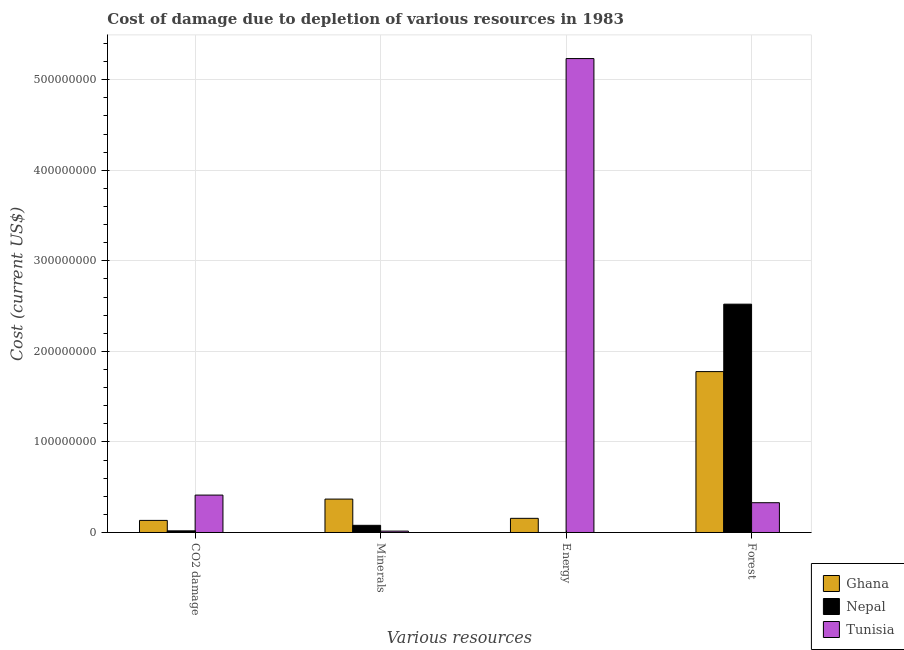How many different coloured bars are there?
Offer a terse response. 3. How many groups of bars are there?
Your answer should be very brief. 4. Are the number of bars per tick equal to the number of legend labels?
Your answer should be compact. Yes. Are the number of bars on each tick of the X-axis equal?
Give a very brief answer. Yes. What is the label of the 2nd group of bars from the left?
Offer a terse response. Minerals. What is the cost of damage due to depletion of energy in Tunisia?
Ensure brevity in your answer.  5.23e+08. Across all countries, what is the maximum cost of damage due to depletion of coal?
Give a very brief answer. 4.13e+07. Across all countries, what is the minimum cost of damage due to depletion of coal?
Your answer should be compact. 1.81e+06. In which country was the cost of damage due to depletion of energy maximum?
Keep it short and to the point. Tunisia. In which country was the cost of damage due to depletion of minerals minimum?
Provide a succinct answer. Tunisia. What is the total cost of damage due to depletion of forests in the graph?
Offer a terse response. 4.63e+08. What is the difference between the cost of damage due to depletion of minerals in Ghana and that in Tunisia?
Ensure brevity in your answer.  3.54e+07. What is the difference between the cost of damage due to depletion of minerals in Nepal and the cost of damage due to depletion of energy in Ghana?
Make the answer very short. -7.73e+06. What is the average cost of damage due to depletion of energy per country?
Give a very brief answer. 1.80e+08. What is the difference between the cost of damage due to depletion of forests and cost of damage due to depletion of coal in Tunisia?
Provide a short and direct response. -8.41e+06. What is the ratio of the cost of damage due to depletion of minerals in Nepal to that in Ghana?
Your answer should be compact. 0.21. Is the cost of damage due to depletion of energy in Ghana less than that in Tunisia?
Offer a terse response. Yes. What is the difference between the highest and the second highest cost of damage due to depletion of coal?
Keep it short and to the point. 2.79e+07. What is the difference between the highest and the lowest cost of damage due to depletion of minerals?
Offer a terse response. 3.54e+07. Is it the case that in every country, the sum of the cost of damage due to depletion of minerals and cost of damage due to depletion of coal is greater than the sum of cost of damage due to depletion of forests and cost of damage due to depletion of energy?
Make the answer very short. No. What does the 1st bar from the left in Forest represents?
Your answer should be compact. Ghana. Is it the case that in every country, the sum of the cost of damage due to depletion of coal and cost of damage due to depletion of minerals is greater than the cost of damage due to depletion of energy?
Keep it short and to the point. No. How many countries are there in the graph?
Provide a short and direct response. 3. Are the values on the major ticks of Y-axis written in scientific E-notation?
Your response must be concise. No. Does the graph contain any zero values?
Offer a very short reply. No. Does the graph contain grids?
Ensure brevity in your answer.  Yes. How many legend labels are there?
Keep it short and to the point. 3. How are the legend labels stacked?
Offer a terse response. Vertical. What is the title of the graph?
Keep it short and to the point. Cost of damage due to depletion of various resources in 1983 . Does "Congo (Democratic)" appear as one of the legend labels in the graph?
Offer a terse response. No. What is the label or title of the X-axis?
Keep it short and to the point. Various resources. What is the label or title of the Y-axis?
Your answer should be very brief. Cost (current US$). What is the Cost (current US$) in Ghana in CO2 damage?
Ensure brevity in your answer.  1.34e+07. What is the Cost (current US$) of Nepal in CO2 damage?
Your answer should be compact. 1.81e+06. What is the Cost (current US$) in Tunisia in CO2 damage?
Keep it short and to the point. 4.13e+07. What is the Cost (current US$) of Ghana in Minerals?
Offer a terse response. 3.69e+07. What is the Cost (current US$) in Nepal in Minerals?
Provide a succinct answer. 7.91e+06. What is the Cost (current US$) in Tunisia in Minerals?
Ensure brevity in your answer.  1.52e+06. What is the Cost (current US$) in Ghana in Energy?
Provide a succinct answer. 1.56e+07. What is the Cost (current US$) in Nepal in Energy?
Give a very brief answer. 1.91e+04. What is the Cost (current US$) in Tunisia in Energy?
Offer a very short reply. 5.23e+08. What is the Cost (current US$) of Ghana in Forest?
Your answer should be compact. 1.78e+08. What is the Cost (current US$) of Nepal in Forest?
Offer a terse response. 2.52e+08. What is the Cost (current US$) of Tunisia in Forest?
Your answer should be compact. 3.29e+07. Across all Various resources, what is the maximum Cost (current US$) of Ghana?
Provide a short and direct response. 1.78e+08. Across all Various resources, what is the maximum Cost (current US$) of Nepal?
Ensure brevity in your answer.  2.52e+08. Across all Various resources, what is the maximum Cost (current US$) in Tunisia?
Offer a terse response. 5.23e+08. Across all Various resources, what is the minimum Cost (current US$) in Ghana?
Your answer should be very brief. 1.34e+07. Across all Various resources, what is the minimum Cost (current US$) in Nepal?
Keep it short and to the point. 1.91e+04. Across all Various resources, what is the minimum Cost (current US$) in Tunisia?
Offer a very short reply. 1.52e+06. What is the total Cost (current US$) of Ghana in the graph?
Give a very brief answer. 2.44e+08. What is the total Cost (current US$) of Nepal in the graph?
Offer a terse response. 2.62e+08. What is the total Cost (current US$) of Tunisia in the graph?
Offer a terse response. 5.99e+08. What is the difference between the Cost (current US$) in Ghana in CO2 damage and that in Minerals?
Give a very brief answer. -2.35e+07. What is the difference between the Cost (current US$) in Nepal in CO2 damage and that in Minerals?
Give a very brief answer. -6.10e+06. What is the difference between the Cost (current US$) in Tunisia in CO2 damage and that in Minerals?
Your answer should be very brief. 3.98e+07. What is the difference between the Cost (current US$) of Ghana in CO2 damage and that in Energy?
Provide a short and direct response. -2.28e+06. What is the difference between the Cost (current US$) of Nepal in CO2 damage and that in Energy?
Your answer should be very brief. 1.79e+06. What is the difference between the Cost (current US$) in Tunisia in CO2 damage and that in Energy?
Offer a very short reply. -4.82e+08. What is the difference between the Cost (current US$) in Ghana in CO2 damage and that in Forest?
Offer a very short reply. -1.64e+08. What is the difference between the Cost (current US$) of Nepal in CO2 damage and that in Forest?
Provide a succinct answer. -2.50e+08. What is the difference between the Cost (current US$) in Tunisia in CO2 damage and that in Forest?
Give a very brief answer. 8.41e+06. What is the difference between the Cost (current US$) of Ghana in Minerals and that in Energy?
Your answer should be very brief. 2.13e+07. What is the difference between the Cost (current US$) of Nepal in Minerals and that in Energy?
Make the answer very short. 7.89e+06. What is the difference between the Cost (current US$) of Tunisia in Minerals and that in Energy?
Provide a short and direct response. -5.22e+08. What is the difference between the Cost (current US$) of Ghana in Minerals and that in Forest?
Keep it short and to the point. -1.41e+08. What is the difference between the Cost (current US$) of Nepal in Minerals and that in Forest?
Ensure brevity in your answer.  -2.44e+08. What is the difference between the Cost (current US$) of Tunisia in Minerals and that in Forest?
Your answer should be compact. -3.14e+07. What is the difference between the Cost (current US$) of Ghana in Energy and that in Forest?
Provide a succinct answer. -1.62e+08. What is the difference between the Cost (current US$) in Nepal in Energy and that in Forest?
Keep it short and to the point. -2.52e+08. What is the difference between the Cost (current US$) of Tunisia in Energy and that in Forest?
Provide a succinct answer. 4.90e+08. What is the difference between the Cost (current US$) in Ghana in CO2 damage and the Cost (current US$) in Nepal in Minerals?
Provide a short and direct response. 5.45e+06. What is the difference between the Cost (current US$) of Ghana in CO2 damage and the Cost (current US$) of Tunisia in Minerals?
Offer a terse response. 1.18e+07. What is the difference between the Cost (current US$) in Nepal in CO2 damage and the Cost (current US$) in Tunisia in Minerals?
Your answer should be compact. 2.86e+05. What is the difference between the Cost (current US$) in Ghana in CO2 damage and the Cost (current US$) in Nepal in Energy?
Your answer should be compact. 1.33e+07. What is the difference between the Cost (current US$) in Ghana in CO2 damage and the Cost (current US$) in Tunisia in Energy?
Provide a succinct answer. -5.10e+08. What is the difference between the Cost (current US$) in Nepal in CO2 damage and the Cost (current US$) in Tunisia in Energy?
Your response must be concise. -5.22e+08. What is the difference between the Cost (current US$) of Ghana in CO2 damage and the Cost (current US$) of Nepal in Forest?
Offer a very short reply. -2.39e+08. What is the difference between the Cost (current US$) in Ghana in CO2 damage and the Cost (current US$) in Tunisia in Forest?
Provide a short and direct response. -1.95e+07. What is the difference between the Cost (current US$) in Nepal in CO2 damage and the Cost (current US$) in Tunisia in Forest?
Your response must be concise. -3.11e+07. What is the difference between the Cost (current US$) in Ghana in Minerals and the Cost (current US$) in Nepal in Energy?
Your answer should be very brief. 3.69e+07. What is the difference between the Cost (current US$) in Ghana in Minerals and the Cost (current US$) in Tunisia in Energy?
Your answer should be very brief. -4.86e+08. What is the difference between the Cost (current US$) in Nepal in Minerals and the Cost (current US$) in Tunisia in Energy?
Offer a terse response. -5.15e+08. What is the difference between the Cost (current US$) in Ghana in Minerals and the Cost (current US$) in Nepal in Forest?
Offer a very short reply. -2.15e+08. What is the difference between the Cost (current US$) in Ghana in Minerals and the Cost (current US$) in Tunisia in Forest?
Offer a terse response. 4.01e+06. What is the difference between the Cost (current US$) in Nepal in Minerals and the Cost (current US$) in Tunisia in Forest?
Offer a very short reply. -2.50e+07. What is the difference between the Cost (current US$) of Ghana in Energy and the Cost (current US$) of Nepal in Forest?
Your response must be concise. -2.37e+08. What is the difference between the Cost (current US$) in Ghana in Energy and the Cost (current US$) in Tunisia in Forest?
Ensure brevity in your answer.  -1.72e+07. What is the difference between the Cost (current US$) of Nepal in Energy and the Cost (current US$) of Tunisia in Forest?
Provide a succinct answer. -3.29e+07. What is the average Cost (current US$) of Ghana per Various resources?
Offer a terse response. 6.09e+07. What is the average Cost (current US$) of Nepal per Various resources?
Give a very brief answer. 6.55e+07. What is the average Cost (current US$) of Tunisia per Various resources?
Ensure brevity in your answer.  1.50e+08. What is the difference between the Cost (current US$) of Ghana and Cost (current US$) of Nepal in CO2 damage?
Offer a very short reply. 1.15e+07. What is the difference between the Cost (current US$) in Ghana and Cost (current US$) in Tunisia in CO2 damage?
Make the answer very short. -2.79e+07. What is the difference between the Cost (current US$) of Nepal and Cost (current US$) of Tunisia in CO2 damage?
Offer a very short reply. -3.95e+07. What is the difference between the Cost (current US$) of Ghana and Cost (current US$) of Nepal in Minerals?
Provide a succinct answer. 2.90e+07. What is the difference between the Cost (current US$) of Ghana and Cost (current US$) of Tunisia in Minerals?
Provide a short and direct response. 3.54e+07. What is the difference between the Cost (current US$) of Nepal and Cost (current US$) of Tunisia in Minerals?
Offer a terse response. 6.38e+06. What is the difference between the Cost (current US$) of Ghana and Cost (current US$) of Nepal in Energy?
Offer a terse response. 1.56e+07. What is the difference between the Cost (current US$) of Ghana and Cost (current US$) of Tunisia in Energy?
Your response must be concise. -5.08e+08. What is the difference between the Cost (current US$) of Nepal and Cost (current US$) of Tunisia in Energy?
Provide a short and direct response. -5.23e+08. What is the difference between the Cost (current US$) in Ghana and Cost (current US$) in Nepal in Forest?
Provide a short and direct response. -7.45e+07. What is the difference between the Cost (current US$) in Ghana and Cost (current US$) in Tunisia in Forest?
Provide a short and direct response. 1.45e+08. What is the difference between the Cost (current US$) in Nepal and Cost (current US$) in Tunisia in Forest?
Give a very brief answer. 2.19e+08. What is the ratio of the Cost (current US$) of Ghana in CO2 damage to that in Minerals?
Your answer should be very brief. 0.36. What is the ratio of the Cost (current US$) in Nepal in CO2 damage to that in Minerals?
Your answer should be very brief. 0.23. What is the ratio of the Cost (current US$) of Tunisia in CO2 damage to that in Minerals?
Provide a succinct answer. 27.13. What is the ratio of the Cost (current US$) in Ghana in CO2 damage to that in Energy?
Offer a very short reply. 0.85. What is the ratio of the Cost (current US$) in Nepal in CO2 damage to that in Energy?
Your answer should be compact. 94.71. What is the ratio of the Cost (current US$) of Tunisia in CO2 damage to that in Energy?
Ensure brevity in your answer.  0.08. What is the ratio of the Cost (current US$) of Ghana in CO2 damage to that in Forest?
Your answer should be compact. 0.08. What is the ratio of the Cost (current US$) in Nepal in CO2 damage to that in Forest?
Keep it short and to the point. 0.01. What is the ratio of the Cost (current US$) of Tunisia in CO2 damage to that in Forest?
Provide a short and direct response. 1.26. What is the ratio of the Cost (current US$) of Ghana in Minerals to that in Energy?
Your answer should be very brief. 2.36. What is the ratio of the Cost (current US$) of Nepal in Minerals to that in Energy?
Provide a succinct answer. 414.09. What is the ratio of the Cost (current US$) in Tunisia in Minerals to that in Energy?
Provide a short and direct response. 0. What is the ratio of the Cost (current US$) of Ghana in Minerals to that in Forest?
Ensure brevity in your answer.  0.21. What is the ratio of the Cost (current US$) of Nepal in Minerals to that in Forest?
Your response must be concise. 0.03. What is the ratio of the Cost (current US$) of Tunisia in Minerals to that in Forest?
Make the answer very short. 0.05. What is the ratio of the Cost (current US$) of Ghana in Energy to that in Forest?
Offer a very short reply. 0.09. What is the ratio of the Cost (current US$) in Nepal in Energy to that in Forest?
Your response must be concise. 0. What is the ratio of the Cost (current US$) in Tunisia in Energy to that in Forest?
Ensure brevity in your answer.  15.92. What is the difference between the highest and the second highest Cost (current US$) in Ghana?
Your answer should be very brief. 1.41e+08. What is the difference between the highest and the second highest Cost (current US$) of Nepal?
Provide a short and direct response. 2.44e+08. What is the difference between the highest and the second highest Cost (current US$) of Tunisia?
Provide a short and direct response. 4.82e+08. What is the difference between the highest and the lowest Cost (current US$) of Ghana?
Provide a succinct answer. 1.64e+08. What is the difference between the highest and the lowest Cost (current US$) of Nepal?
Your answer should be compact. 2.52e+08. What is the difference between the highest and the lowest Cost (current US$) of Tunisia?
Your answer should be very brief. 5.22e+08. 